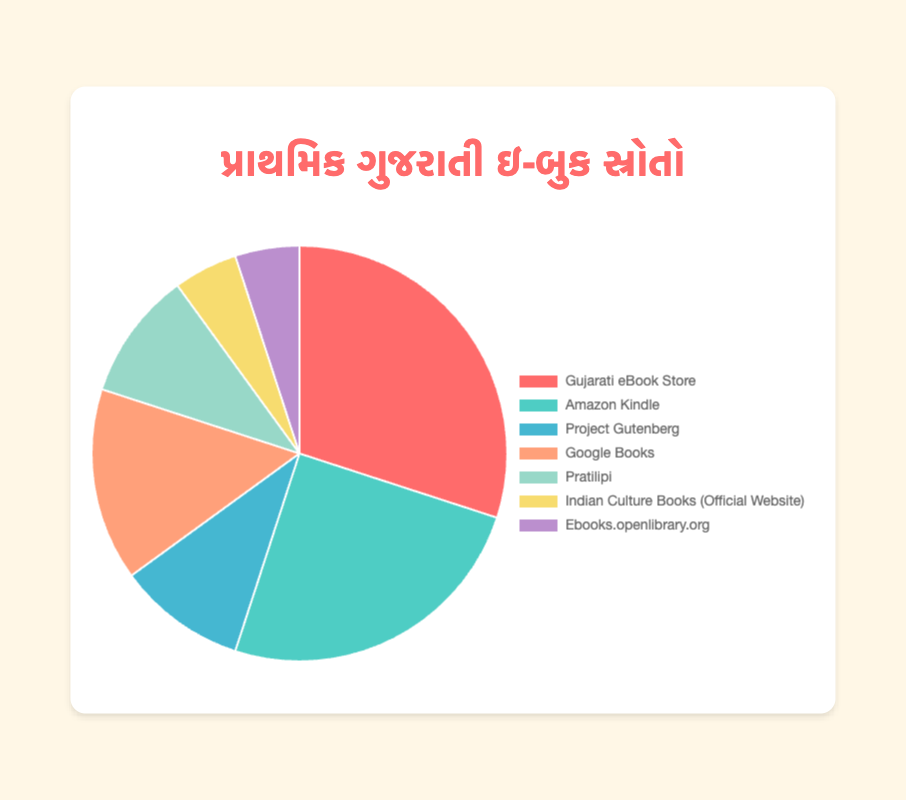Which source contributes the highest percentage to the Gujarati eBook market? By looking at the slices, the largest slice corresponds to "Gujarati eBook Store" with 30%.
Answer: Gujarati eBook Store What is the combined percentage of eBooks sourced from Project Gutenberg and Pratilipi? Adding the percentages of Project Gutenberg (10%) and Pratilipi (10%) results in 10 + 10 = 20.
Answer: 20% Is the contribution of Google Books greater than Amazon Kindle? Comparing their slices, Google Books has 15% while Amazon Kindle has 25%. So, Amazon Kindle has a greater contribution.
Answer: No What is the average percentage of the contributions from Indian Culture Books (Official Website) and Ebooks.openlibrary.org? Both sources have 5%, so (5 + 5) / 2 = 5.
Answer: 5% Which source is represented by the green slice in the pie chart? Observing the colors, the green slice represents Amazon Kindle.
Answer: Amazon Kindle Which two sources each contribute 10% to the market? From the pie chart, Project Gutenberg and Pratilipi each contribute 10%.
Answer: Project Gutenberg, Pratilipi By how much does the contribution of the Gujarati eBook Store exceed that of Project Gutenberg? Subtracting the percentages: 30% (Gujarati eBook Store) - 10% (Project Gutenberg) = 20%.
Answer: 20% What is the total contribution of sources other than the three highest contributors? The three highest contributors are Gujarati eBook Store (30%), Amazon Kindle (25%), and Google Books (15%), summing to 70%. The total percentage must be 100%, so 100 - 70 = 30% for the remaining sources.
Answer: 30% Is the percentage contribution from Ebooks.openlibrary.org the same as from Indian Culture Books (Official Website)? Both have a percentage of 5%, as represented by equal-sized slices.
Answer: Yes 